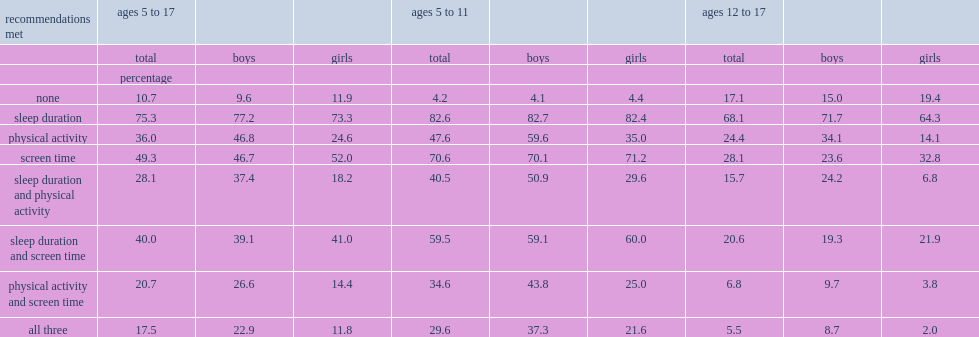What was the percentage of children aged 5 to 17 who met the screen-time recommendation. 49.3. What was the percentage of children aged 5 to 17 who met the sleep recommendation? 75.3. Which age group were more likely to meet the recommendations for mvpa? Ages 5 to 11. What was the percentage of boys and girls meeting the mvpa recommendation respectively? 46.8 24.6. What was the percentage of boys and girls aged 5 to 11 meeting the mvpa recommendation respectively? 59.6 35.0. Among youth (but not children,aged 12 to 17),who had a higher percentage of meeting the screen-time recommendation,boys or girls? Girls. 